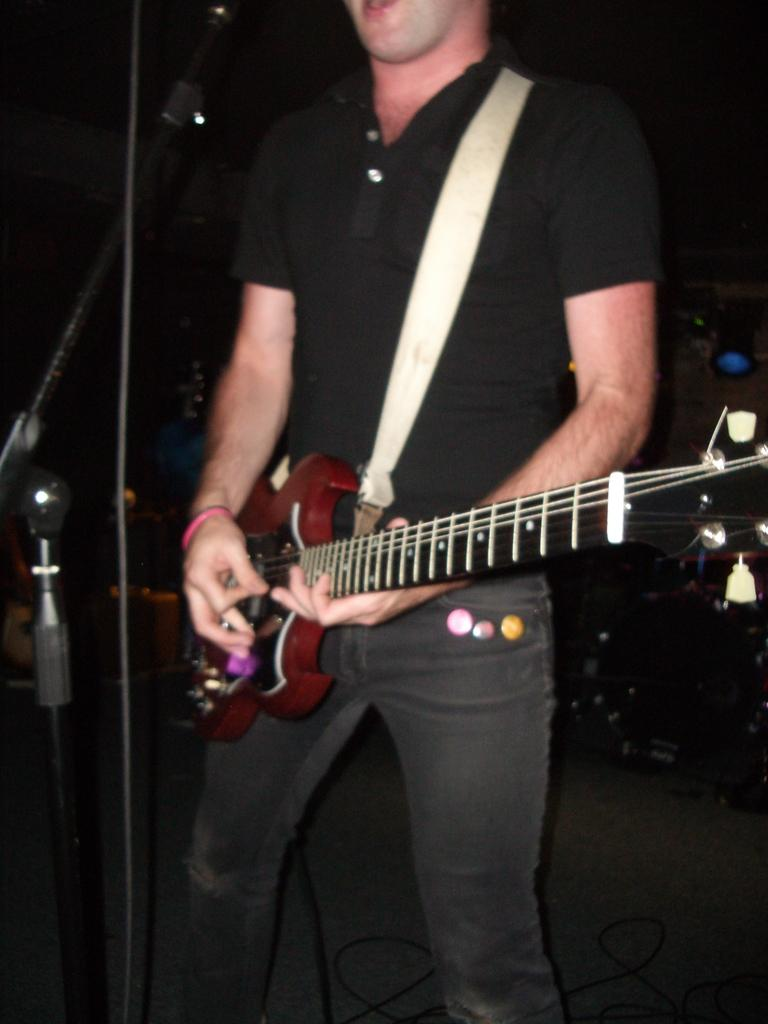What is the person in the image doing? The person is playing a guitar. What is the person using to amplify their voice in the image? There is a microphone in front of the person. What is supporting the microphone in the image? There is a stand associated with the microphone. What can be inferred about the lighting conditions in the image? The background of the image is dark. What type of stick can be seen being used by the person in the image? There is no stick visible in the image; the person is playing a guitar and using a microphone. 